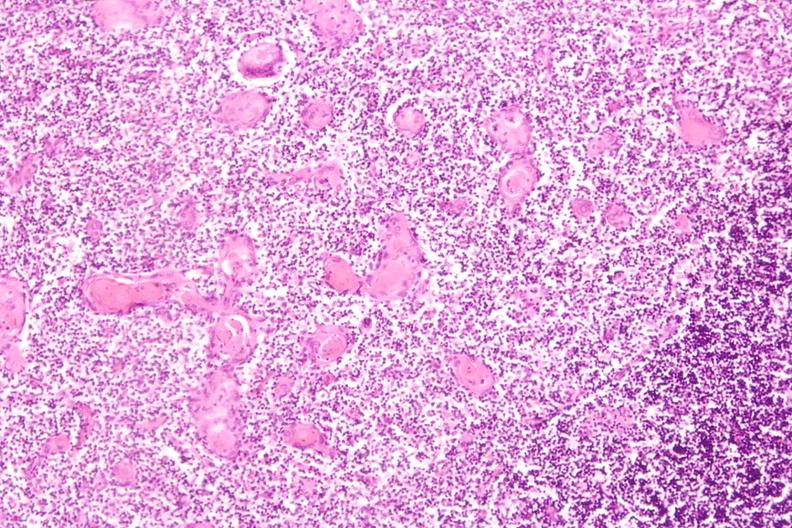s cardiovascular present?
Answer the question using a single word or phrase. No 